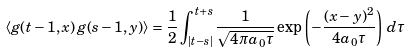Convert formula to latex. <formula><loc_0><loc_0><loc_500><loc_500>\left \langle g ( t - 1 , x ) \, g ( s - 1 , y ) \right \rangle = \frac { 1 } { 2 } \int _ { | t - s | } ^ { t + s } \frac { 1 } { \sqrt { 4 \pi a _ { 0 } \tau } } \exp \left ( - \frac { ( x - y ) ^ { 2 } } { 4 a _ { 0 } \tau } \right ) \, d \tau \,</formula> 